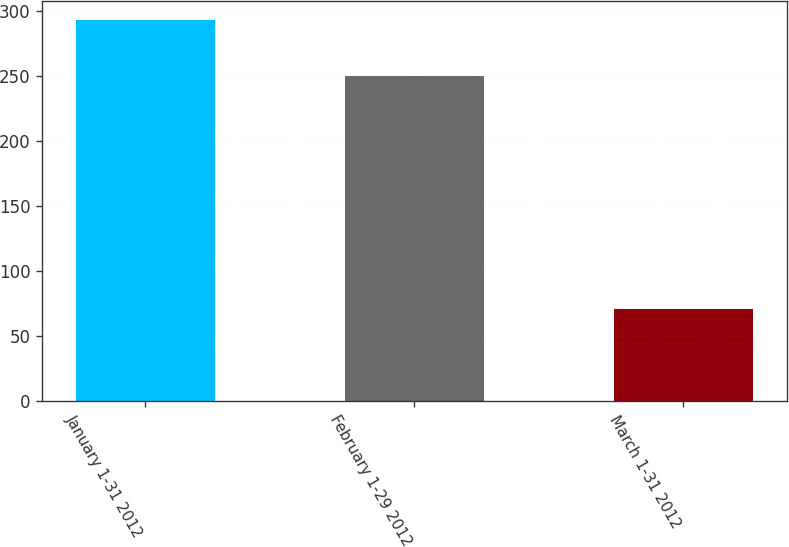Convert chart to OTSL. <chart><loc_0><loc_0><loc_500><loc_500><bar_chart><fcel>January 1-31 2012<fcel>February 1-29 2012<fcel>March 1-31 2012<nl><fcel>293<fcel>250<fcel>71<nl></chart> 